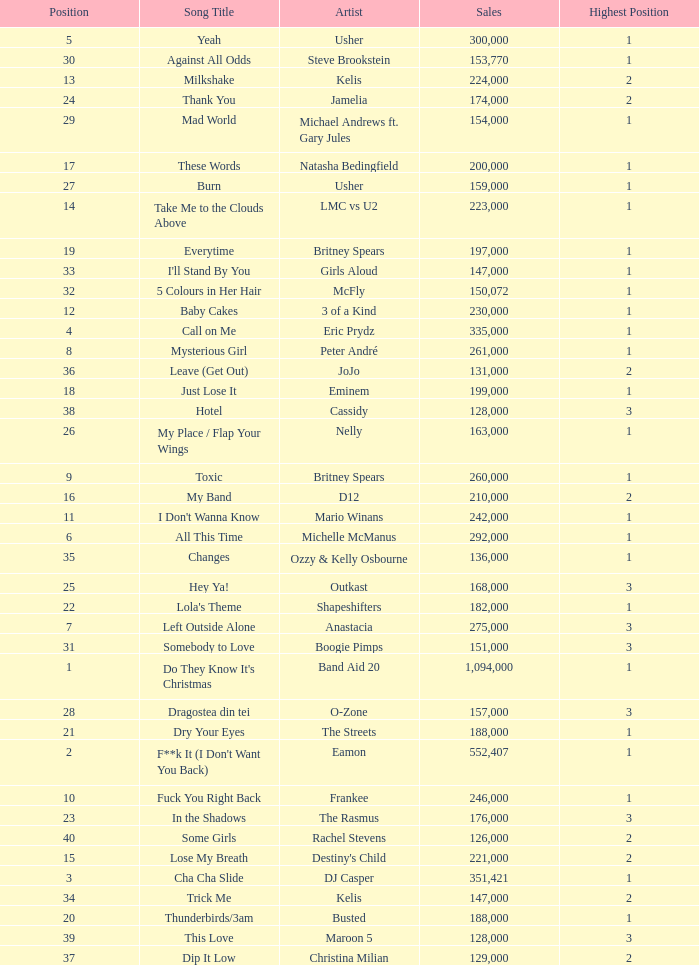What were the sales for Dj Casper when he was in a position lower than 13? 351421.0. 